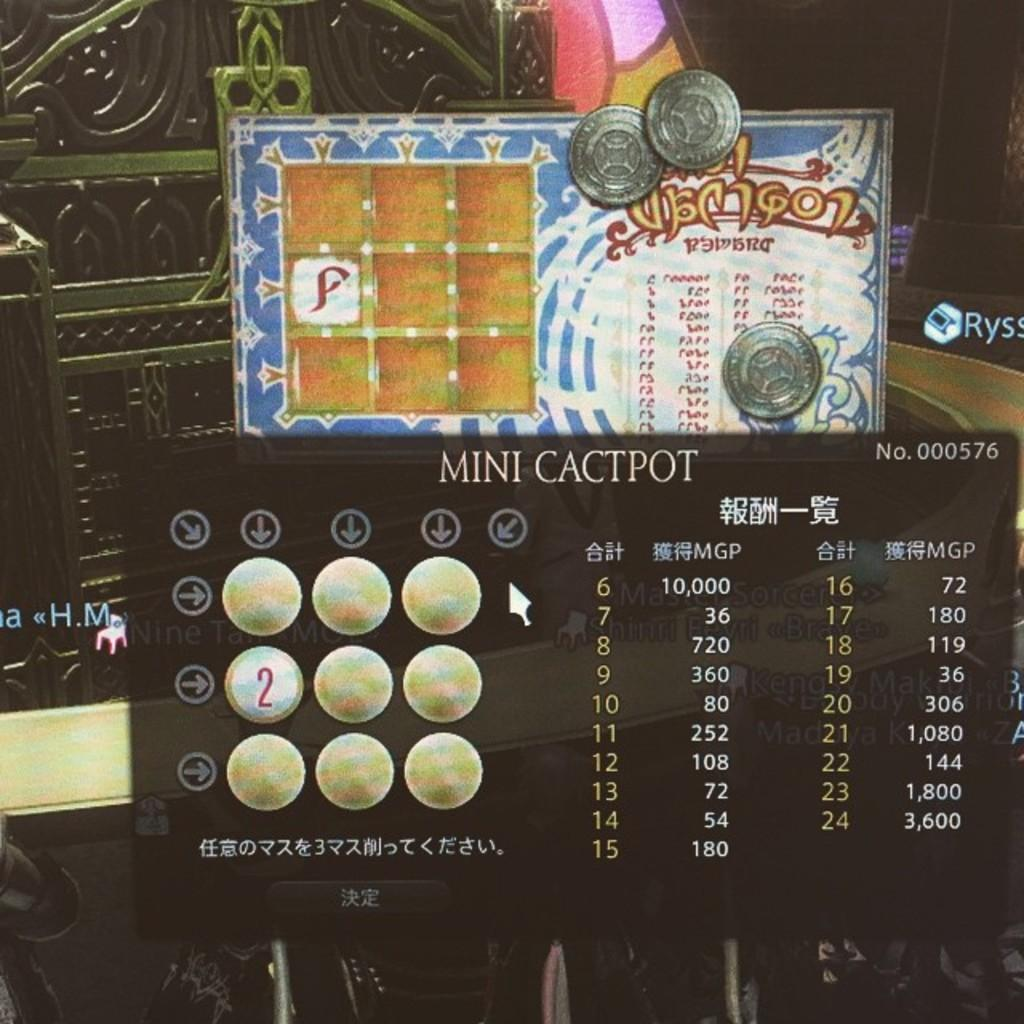<image>
Provide a brief description of the given image. A called Mini Cactpot is on display on a screen 